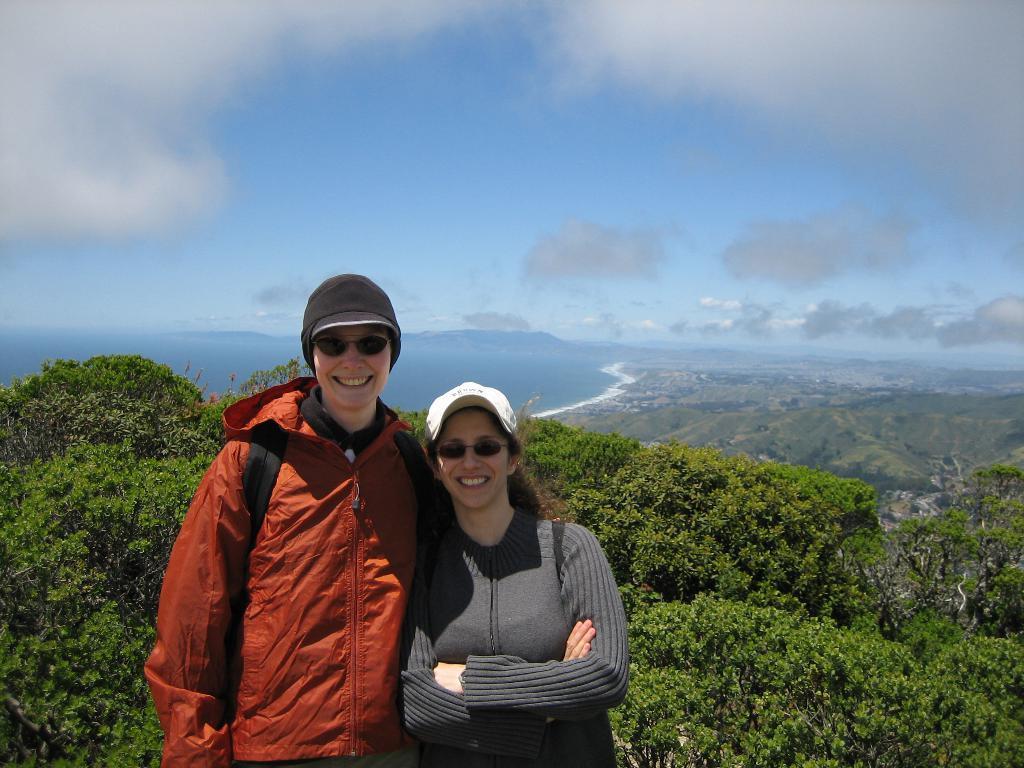In one or two sentences, can you explain what this image depicts? In this picture there is a man and woman standing and smiling. There is a tree. sky is blue and cloudy. 